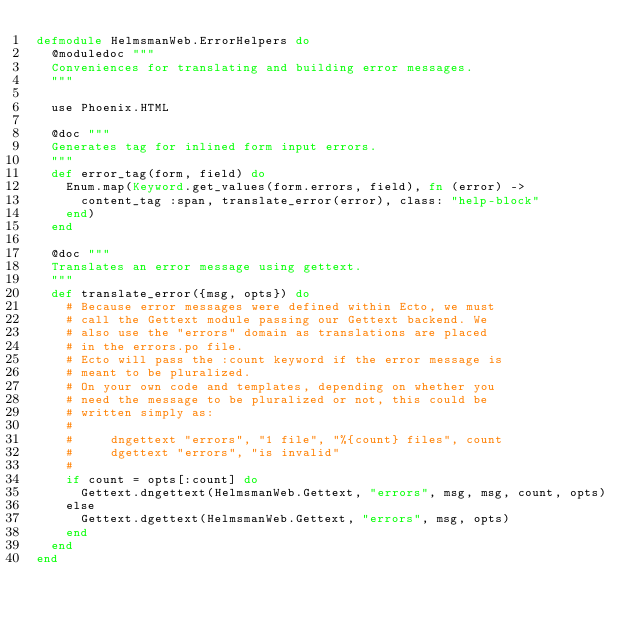Convert code to text. <code><loc_0><loc_0><loc_500><loc_500><_Elixir_>defmodule HelmsmanWeb.ErrorHelpers do
  @moduledoc """
  Conveniences for translating and building error messages.
  """

  use Phoenix.HTML

  @doc """
  Generates tag for inlined form input errors.
  """
  def error_tag(form, field) do
    Enum.map(Keyword.get_values(form.errors, field), fn (error) ->
      content_tag :span, translate_error(error), class: "help-block"
    end)
  end

  @doc """
  Translates an error message using gettext.
  """
  def translate_error({msg, opts}) do
    # Because error messages were defined within Ecto, we must
    # call the Gettext module passing our Gettext backend. We
    # also use the "errors" domain as translations are placed
    # in the errors.po file.
    # Ecto will pass the :count keyword if the error message is
    # meant to be pluralized.
    # On your own code and templates, depending on whether you
    # need the message to be pluralized or not, this could be
    # written simply as:
    #
    #     dngettext "errors", "1 file", "%{count} files", count
    #     dgettext "errors", "is invalid"
    #
    if count = opts[:count] do
      Gettext.dngettext(HelmsmanWeb.Gettext, "errors", msg, msg, count, opts)
    else
      Gettext.dgettext(HelmsmanWeb.Gettext, "errors", msg, opts)
    end
  end
end
</code> 